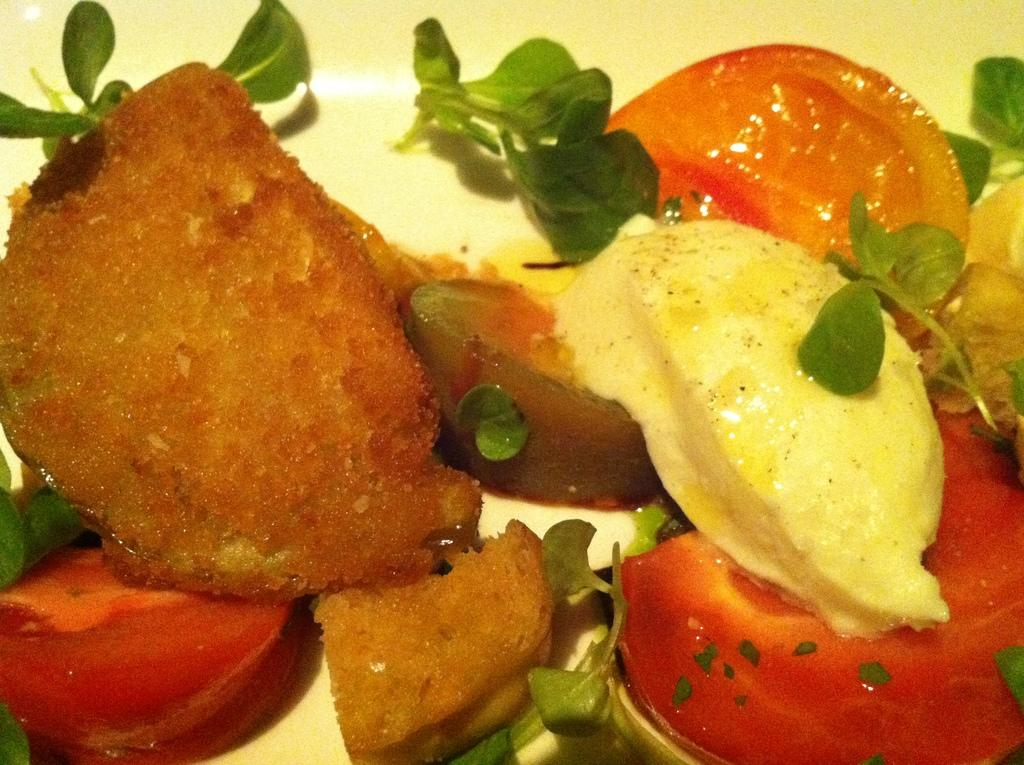What is on the plate that is visible in the image? The plate contains fruit slices and ice cream. What type of garnish is present on the plate? There is leaf garnish on the plate. How many chickens are present on the plate in the image? There are no chickens present on the plate in the image. What type of division is being performed on the plate in the image? There is no division being performed on the plate in the image. 